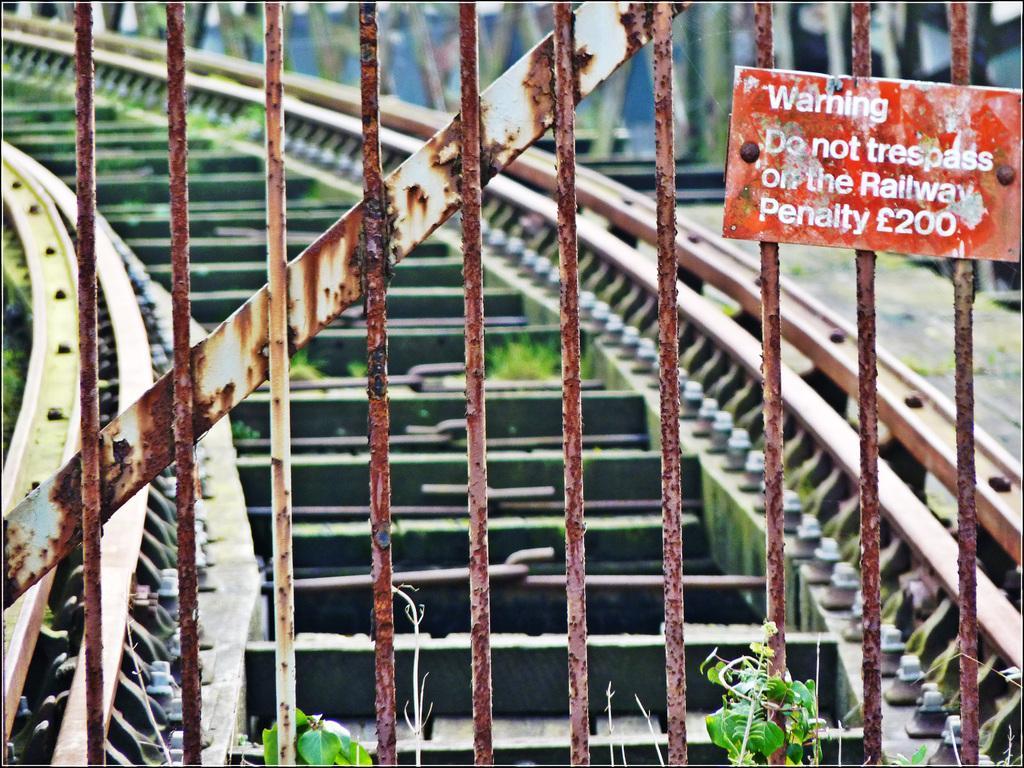Could you give a brief overview of what you see in this image? In this image I can see the iron gate and the board to it. And there is something return on the board. In the back I can see the track. And I can see the blurred background 